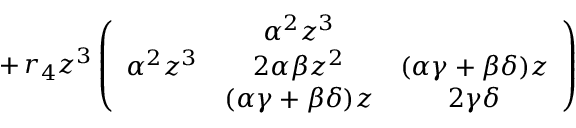<formula> <loc_0><loc_0><loc_500><loc_500>\, + \, r _ { 4 } z ^ { 3 } \left ( \begin{array} { c c c & { { \alpha ^ { 2 } z ^ { 3 } } } \\ { { \alpha ^ { 2 } z ^ { 3 } } } & { { 2 \alpha \beta z ^ { 2 } } } & { ( \alpha \gamma + \beta \delta ) z } & { ( \alpha \gamma + \beta \delta ) z } & { 2 \gamma \delta } \end{array} \right )</formula> 